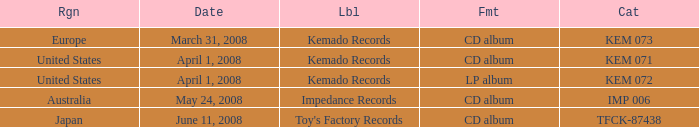Which Label has a Region of united states, and a Format of lp album? Kemado Records. 